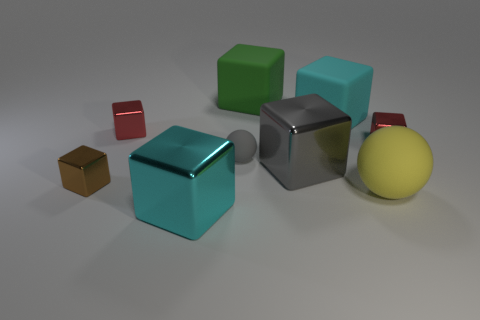Are there fewer tiny brown shiny things that are in front of the brown object than large metal objects?
Your answer should be compact. Yes. There is a block that is behind the cyan thing on the right side of the big gray cube; what is its material?
Ensure brevity in your answer.  Rubber. What is the shape of the object that is right of the big gray metal block and in front of the small gray matte ball?
Your answer should be compact. Sphere. How many other objects are the same color as the small rubber object?
Provide a short and direct response. 1. What number of things are either cyan cubes behind the brown metal block or shiny cubes?
Offer a terse response. 6. Do the small sphere and the large metallic block that is behind the big sphere have the same color?
Offer a terse response. Yes. There is a cyan block in front of the tiny metal object right of the big yellow matte sphere; what size is it?
Keep it short and to the point. Large. What number of objects are either small gray rubber things or rubber objects in front of the small brown metallic thing?
Ensure brevity in your answer.  2. There is a large cyan object in front of the cyan matte object; is it the same shape as the small gray thing?
Give a very brief answer. No. What number of red objects are on the right side of the matte ball that is left of the ball to the right of the green thing?
Provide a succinct answer. 1. 